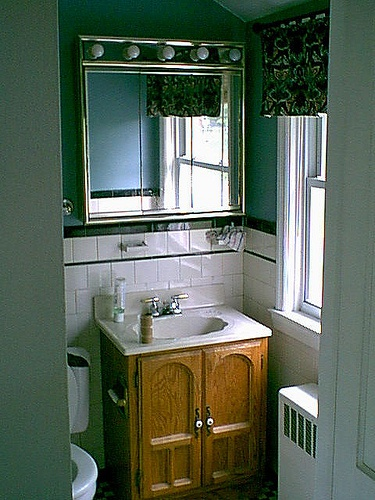Describe the objects in this image and their specific colors. I can see sink in darkgreen, darkgray, lavender, and gray tones, toilet in darkgreen, gray, black, and darkgray tones, bottle in darkgreen, gray, black, and darkgray tones, and bottle in darkgreen, darkgray, gray, and lightblue tones in this image. 